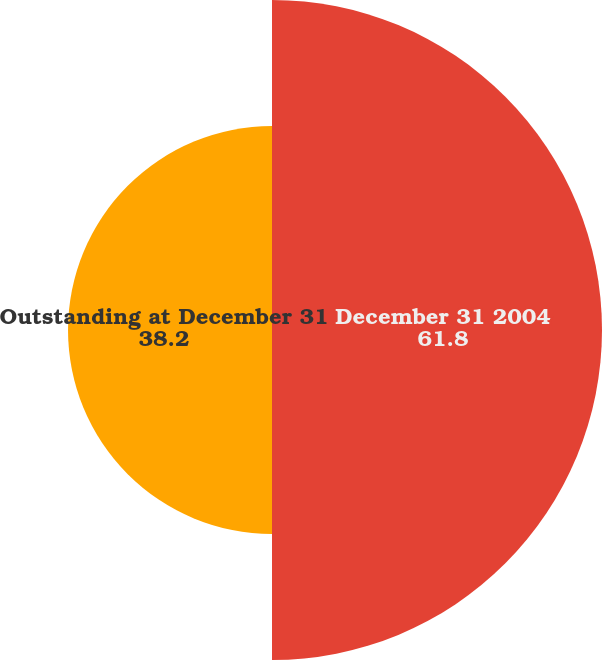<chart> <loc_0><loc_0><loc_500><loc_500><pie_chart><fcel>December 31 2004<fcel>Outstanding at December 31<nl><fcel>61.8%<fcel>38.2%<nl></chart> 